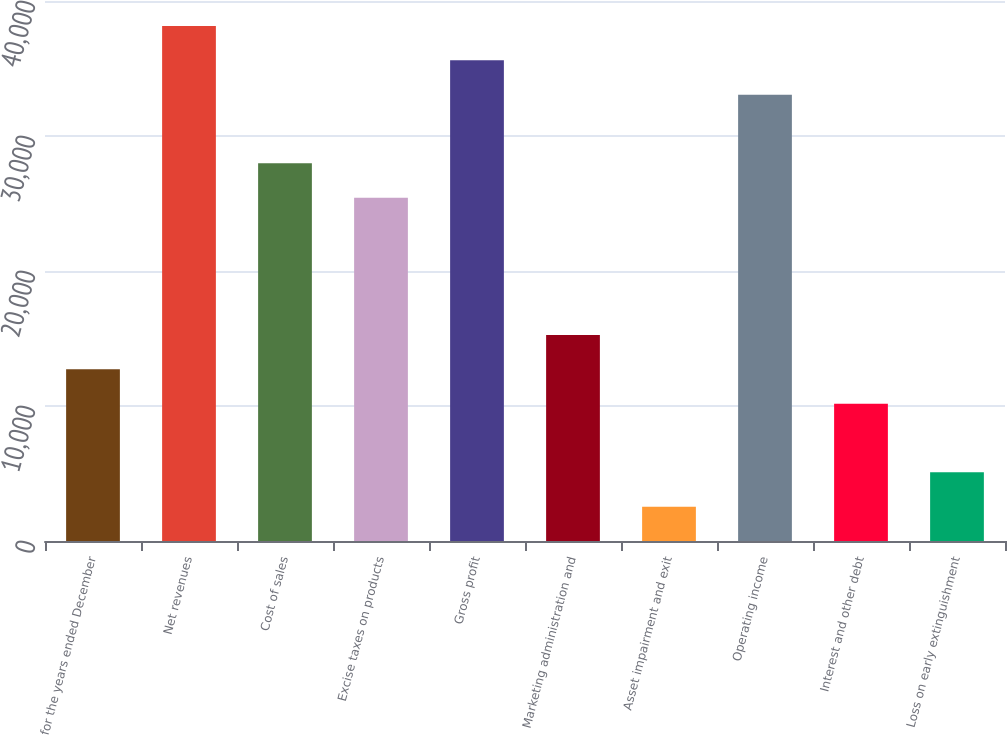Convert chart. <chart><loc_0><loc_0><loc_500><loc_500><bar_chart><fcel>for the years ended December<fcel>Net revenues<fcel>Cost of sales<fcel>Excise taxes on products<fcel>Gross profit<fcel>Marketing administration and<fcel>Asset impairment and exit<fcel>Operating income<fcel>Interest and other debt<fcel>Loss on early extinguishment<nl><fcel>12718.3<fcel>38149.6<fcel>27977.1<fcel>25434<fcel>35606.5<fcel>15261.5<fcel>2545.8<fcel>33063.4<fcel>10175.2<fcel>5088.93<nl></chart> 